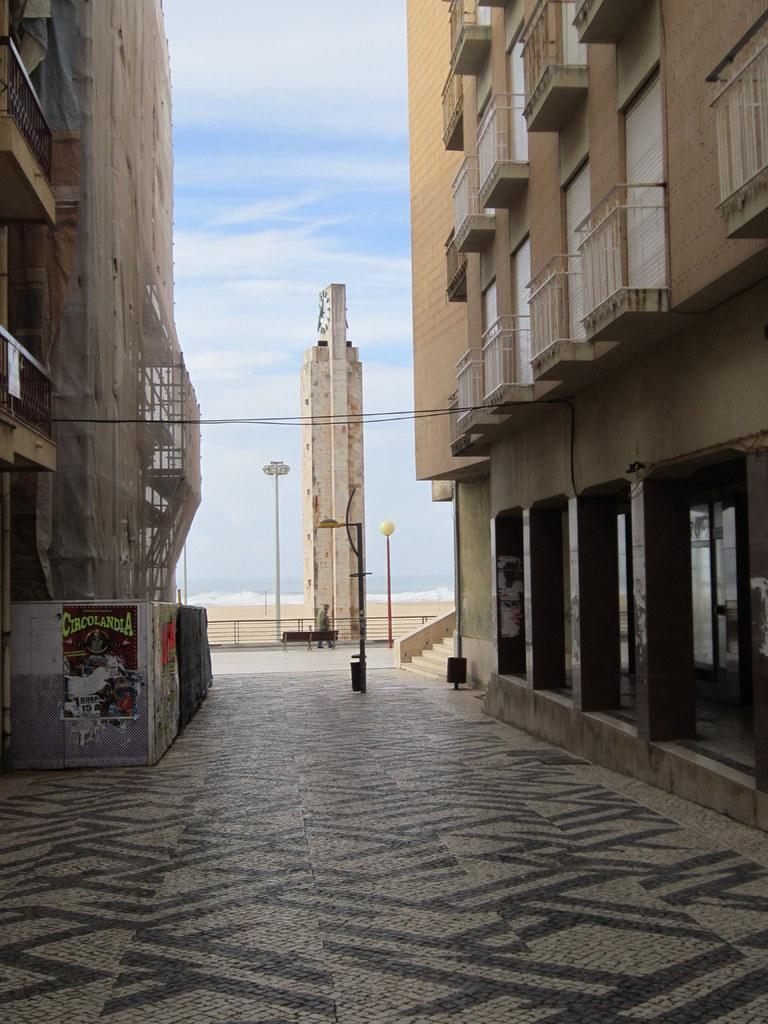What type of structures are present in the image? There are buildings in the image. Is there any indication of a path or route between the buildings? Yes, there is a path between the buildings in the image. Are there any architectural features within the buildings? Yes, there are staircases in the image. Can you describe any activity taking place in the image? One person is walking in the image. What type of food is being served for dinner in the image? There is no reference to food or dinner in the image; it primarily features buildings, a path, staircases, and a person walking. 